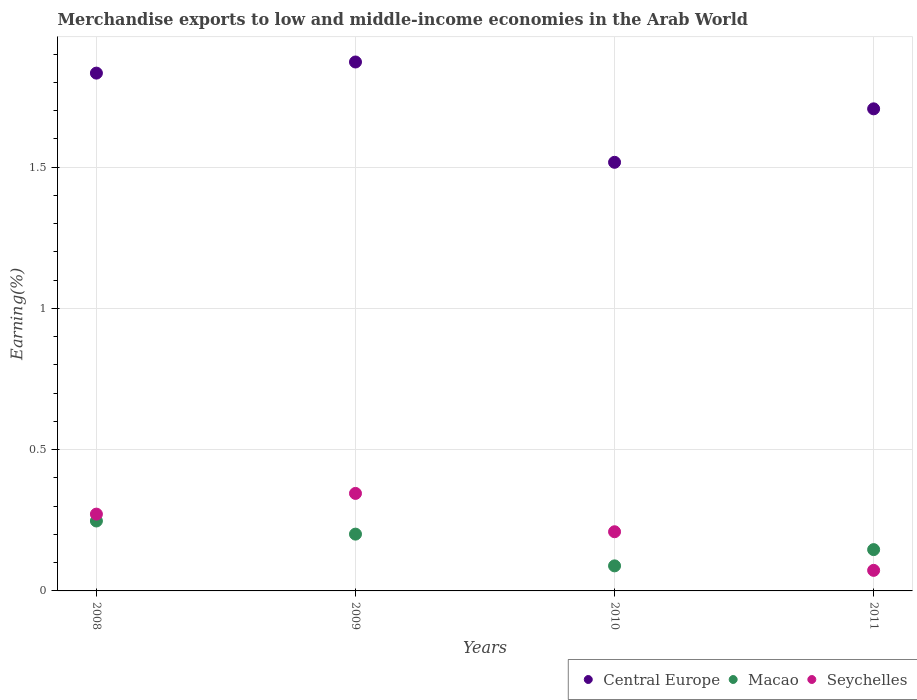How many different coloured dotlines are there?
Make the answer very short. 3. Is the number of dotlines equal to the number of legend labels?
Make the answer very short. Yes. What is the percentage of amount earned from merchandise exports in Seychelles in 2010?
Keep it short and to the point. 0.21. Across all years, what is the maximum percentage of amount earned from merchandise exports in Seychelles?
Provide a short and direct response. 0.35. Across all years, what is the minimum percentage of amount earned from merchandise exports in Central Europe?
Ensure brevity in your answer.  1.52. In which year was the percentage of amount earned from merchandise exports in Central Europe maximum?
Keep it short and to the point. 2009. In which year was the percentage of amount earned from merchandise exports in Macao minimum?
Your answer should be very brief. 2010. What is the total percentage of amount earned from merchandise exports in Central Europe in the graph?
Your answer should be compact. 6.93. What is the difference between the percentage of amount earned from merchandise exports in Seychelles in 2008 and that in 2010?
Provide a short and direct response. 0.06. What is the difference between the percentage of amount earned from merchandise exports in Seychelles in 2008 and the percentage of amount earned from merchandise exports in Macao in 2009?
Your answer should be very brief. 0.07. What is the average percentage of amount earned from merchandise exports in Seychelles per year?
Keep it short and to the point. 0.22. In the year 2008, what is the difference between the percentage of amount earned from merchandise exports in Central Europe and percentage of amount earned from merchandise exports in Macao?
Give a very brief answer. 1.59. In how many years, is the percentage of amount earned from merchandise exports in Macao greater than 1.2 %?
Provide a succinct answer. 0. What is the ratio of the percentage of amount earned from merchandise exports in Central Europe in 2010 to that in 2011?
Offer a very short reply. 0.89. Is the percentage of amount earned from merchandise exports in Seychelles in 2008 less than that in 2010?
Make the answer very short. No. What is the difference between the highest and the second highest percentage of amount earned from merchandise exports in Central Europe?
Provide a succinct answer. 0.04. What is the difference between the highest and the lowest percentage of amount earned from merchandise exports in Central Europe?
Ensure brevity in your answer.  0.36. In how many years, is the percentage of amount earned from merchandise exports in Central Europe greater than the average percentage of amount earned from merchandise exports in Central Europe taken over all years?
Your answer should be compact. 2. Is it the case that in every year, the sum of the percentage of amount earned from merchandise exports in Central Europe and percentage of amount earned from merchandise exports in Seychelles  is greater than the percentage of amount earned from merchandise exports in Macao?
Give a very brief answer. Yes. Does the percentage of amount earned from merchandise exports in Seychelles monotonically increase over the years?
Your response must be concise. No. Are the values on the major ticks of Y-axis written in scientific E-notation?
Offer a very short reply. No. Does the graph contain any zero values?
Make the answer very short. No. Does the graph contain grids?
Your answer should be compact. Yes. Where does the legend appear in the graph?
Provide a succinct answer. Bottom right. How are the legend labels stacked?
Provide a succinct answer. Horizontal. What is the title of the graph?
Make the answer very short. Merchandise exports to low and middle-income economies in the Arab World. What is the label or title of the Y-axis?
Your answer should be compact. Earning(%). What is the Earning(%) in Central Europe in 2008?
Ensure brevity in your answer.  1.83. What is the Earning(%) in Macao in 2008?
Provide a succinct answer. 0.25. What is the Earning(%) in Seychelles in 2008?
Provide a succinct answer. 0.27. What is the Earning(%) in Central Europe in 2009?
Offer a terse response. 1.87. What is the Earning(%) of Macao in 2009?
Offer a very short reply. 0.2. What is the Earning(%) in Seychelles in 2009?
Give a very brief answer. 0.35. What is the Earning(%) in Central Europe in 2010?
Offer a very short reply. 1.52. What is the Earning(%) of Macao in 2010?
Ensure brevity in your answer.  0.09. What is the Earning(%) in Seychelles in 2010?
Keep it short and to the point. 0.21. What is the Earning(%) of Central Europe in 2011?
Ensure brevity in your answer.  1.71. What is the Earning(%) of Macao in 2011?
Provide a short and direct response. 0.15. What is the Earning(%) of Seychelles in 2011?
Your answer should be very brief. 0.07. Across all years, what is the maximum Earning(%) of Central Europe?
Your answer should be compact. 1.87. Across all years, what is the maximum Earning(%) of Macao?
Provide a succinct answer. 0.25. Across all years, what is the maximum Earning(%) in Seychelles?
Make the answer very short. 0.35. Across all years, what is the minimum Earning(%) of Central Europe?
Your answer should be compact. 1.52. Across all years, what is the minimum Earning(%) in Macao?
Offer a very short reply. 0.09. Across all years, what is the minimum Earning(%) in Seychelles?
Keep it short and to the point. 0.07. What is the total Earning(%) of Central Europe in the graph?
Ensure brevity in your answer.  6.93. What is the total Earning(%) in Macao in the graph?
Offer a terse response. 0.68. What is the total Earning(%) in Seychelles in the graph?
Provide a short and direct response. 0.9. What is the difference between the Earning(%) of Central Europe in 2008 and that in 2009?
Make the answer very short. -0.04. What is the difference between the Earning(%) of Macao in 2008 and that in 2009?
Keep it short and to the point. 0.05. What is the difference between the Earning(%) of Seychelles in 2008 and that in 2009?
Ensure brevity in your answer.  -0.07. What is the difference between the Earning(%) in Central Europe in 2008 and that in 2010?
Your response must be concise. 0.32. What is the difference between the Earning(%) in Macao in 2008 and that in 2010?
Make the answer very short. 0.16. What is the difference between the Earning(%) in Seychelles in 2008 and that in 2010?
Give a very brief answer. 0.06. What is the difference between the Earning(%) of Central Europe in 2008 and that in 2011?
Make the answer very short. 0.13. What is the difference between the Earning(%) of Macao in 2008 and that in 2011?
Provide a succinct answer. 0.1. What is the difference between the Earning(%) of Seychelles in 2008 and that in 2011?
Keep it short and to the point. 0.2. What is the difference between the Earning(%) in Central Europe in 2009 and that in 2010?
Ensure brevity in your answer.  0.36. What is the difference between the Earning(%) of Macao in 2009 and that in 2010?
Offer a terse response. 0.11. What is the difference between the Earning(%) in Seychelles in 2009 and that in 2010?
Keep it short and to the point. 0.14. What is the difference between the Earning(%) of Central Europe in 2009 and that in 2011?
Offer a terse response. 0.17. What is the difference between the Earning(%) of Macao in 2009 and that in 2011?
Offer a terse response. 0.05. What is the difference between the Earning(%) of Seychelles in 2009 and that in 2011?
Ensure brevity in your answer.  0.27. What is the difference between the Earning(%) in Central Europe in 2010 and that in 2011?
Provide a succinct answer. -0.19. What is the difference between the Earning(%) in Macao in 2010 and that in 2011?
Your answer should be very brief. -0.06. What is the difference between the Earning(%) of Seychelles in 2010 and that in 2011?
Provide a short and direct response. 0.14. What is the difference between the Earning(%) of Central Europe in 2008 and the Earning(%) of Macao in 2009?
Offer a very short reply. 1.63. What is the difference between the Earning(%) in Central Europe in 2008 and the Earning(%) in Seychelles in 2009?
Offer a terse response. 1.49. What is the difference between the Earning(%) of Macao in 2008 and the Earning(%) of Seychelles in 2009?
Give a very brief answer. -0.1. What is the difference between the Earning(%) in Central Europe in 2008 and the Earning(%) in Macao in 2010?
Your answer should be very brief. 1.74. What is the difference between the Earning(%) in Central Europe in 2008 and the Earning(%) in Seychelles in 2010?
Your answer should be compact. 1.62. What is the difference between the Earning(%) of Macao in 2008 and the Earning(%) of Seychelles in 2010?
Keep it short and to the point. 0.04. What is the difference between the Earning(%) in Central Europe in 2008 and the Earning(%) in Macao in 2011?
Make the answer very short. 1.69. What is the difference between the Earning(%) of Central Europe in 2008 and the Earning(%) of Seychelles in 2011?
Make the answer very short. 1.76. What is the difference between the Earning(%) in Macao in 2008 and the Earning(%) in Seychelles in 2011?
Offer a terse response. 0.17. What is the difference between the Earning(%) of Central Europe in 2009 and the Earning(%) of Macao in 2010?
Your answer should be very brief. 1.78. What is the difference between the Earning(%) of Central Europe in 2009 and the Earning(%) of Seychelles in 2010?
Provide a short and direct response. 1.66. What is the difference between the Earning(%) in Macao in 2009 and the Earning(%) in Seychelles in 2010?
Provide a short and direct response. -0.01. What is the difference between the Earning(%) in Central Europe in 2009 and the Earning(%) in Macao in 2011?
Provide a succinct answer. 1.73. What is the difference between the Earning(%) of Central Europe in 2009 and the Earning(%) of Seychelles in 2011?
Make the answer very short. 1.8. What is the difference between the Earning(%) of Macao in 2009 and the Earning(%) of Seychelles in 2011?
Your response must be concise. 0.13. What is the difference between the Earning(%) of Central Europe in 2010 and the Earning(%) of Macao in 2011?
Provide a short and direct response. 1.37. What is the difference between the Earning(%) in Central Europe in 2010 and the Earning(%) in Seychelles in 2011?
Offer a very short reply. 1.44. What is the difference between the Earning(%) of Macao in 2010 and the Earning(%) of Seychelles in 2011?
Your answer should be compact. 0.02. What is the average Earning(%) of Central Europe per year?
Give a very brief answer. 1.73. What is the average Earning(%) in Macao per year?
Make the answer very short. 0.17. What is the average Earning(%) of Seychelles per year?
Offer a very short reply. 0.22. In the year 2008, what is the difference between the Earning(%) in Central Europe and Earning(%) in Macao?
Offer a very short reply. 1.59. In the year 2008, what is the difference between the Earning(%) in Central Europe and Earning(%) in Seychelles?
Provide a succinct answer. 1.56. In the year 2008, what is the difference between the Earning(%) in Macao and Earning(%) in Seychelles?
Offer a terse response. -0.02. In the year 2009, what is the difference between the Earning(%) of Central Europe and Earning(%) of Macao?
Offer a very short reply. 1.67. In the year 2009, what is the difference between the Earning(%) of Central Europe and Earning(%) of Seychelles?
Provide a short and direct response. 1.53. In the year 2009, what is the difference between the Earning(%) of Macao and Earning(%) of Seychelles?
Keep it short and to the point. -0.14. In the year 2010, what is the difference between the Earning(%) in Central Europe and Earning(%) in Macao?
Provide a short and direct response. 1.43. In the year 2010, what is the difference between the Earning(%) of Central Europe and Earning(%) of Seychelles?
Offer a terse response. 1.31. In the year 2010, what is the difference between the Earning(%) in Macao and Earning(%) in Seychelles?
Your answer should be compact. -0.12. In the year 2011, what is the difference between the Earning(%) in Central Europe and Earning(%) in Macao?
Your response must be concise. 1.56. In the year 2011, what is the difference between the Earning(%) of Central Europe and Earning(%) of Seychelles?
Your answer should be compact. 1.63. In the year 2011, what is the difference between the Earning(%) in Macao and Earning(%) in Seychelles?
Offer a terse response. 0.07. What is the ratio of the Earning(%) in Central Europe in 2008 to that in 2009?
Give a very brief answer. 0.98. What is the ratio of the Earning(%) of Macao in 2008 to that in 2009?
Your answer should be compact. 1.23. What is the ratio of the Earning(%) of Seychelles in 2008 to that in 2009?
Provide a succinct answer. 0.79. What is the ratio of the Earning(%) in Central Europe in 2008 to that in 2010?
Offer a very short reply. 1.21. What is the ratio of the Earning(%) of Macao in 2008 to that in 2010?
Provide a short and direct response. 2.79. What is the ratio of the Earning(%) in Seychelles in 2008 to that in 2010?
Make the answer very short. 1.3. What is the ratio of the Earning(%) in Central Europe in 2008 to that in 2011?
Make the answer very short. 1.07. What is the ratio of the Earning(%) in Macao in 2008 to that in 2011?
Your answer should be compact. 1.69. What is the ratio of the Earning(%) of Seychelles in 2008 to that in 2011?
Your answer should be compact. 3.73. What is the ratio of the Earning(%) of Central Europe in 2009 to that in 2010?
Make the answer very short. 1.23. What is the ratio of the Earning(%) in Macao in 2009 to that in 2010?
Your answer should be compact. 2.27. What is the ratio of the Earning(%) in Seychelles in 2009 to that in 2010?
Provide a succinct answer. 1.65. What is the ratio of the Earning(%) of Central Europe in 2009 to that in 2011?
Give a very brief answer. 1.1. What is the ratio of the Earning(%) of Macao in 2009 to that in 2011?
Offer a very short reply. 1.38. What is the ratio of the Earning(%) of Seychelles in 2009 to that in 2011?
Offer a terse response. 4.74. What is the ratio of the Earning(%) in Central Europe in 2010 to that in 2011?
Provide a short and direct response. 0.89. What is the ratio of the Earning(%) in Macao in 2010 to that in 2011?
Your response must be concise. 0.61. What is the ratio of the Earning(%) in Seychelles in 2010 to that in 2011?
Provide a succinct answer. 2.88. What is the difference between the highest and the second highest Earning(%) of Central Europe?
Offer a terse response. 0.04. What is the difference between the highest and the second highest Earning(%) in Macao?
Your answer should be compact. 0.05. What is the difference between the highest and the second highest Earning(%) in Seychelles?
Give a very brief answer. 0.07. What is the difference between the highest and the lowest Earning(%) in Central Europe?
Provide a short and direct response. 0.36. What is the difference between the highest and the lowest Earning(%) of Macao?
Make the answer very short. 0.16. What is the difference between the highest and the lowest Earning(%) in Seychelles?
Offer a very short reply. 0.27. 